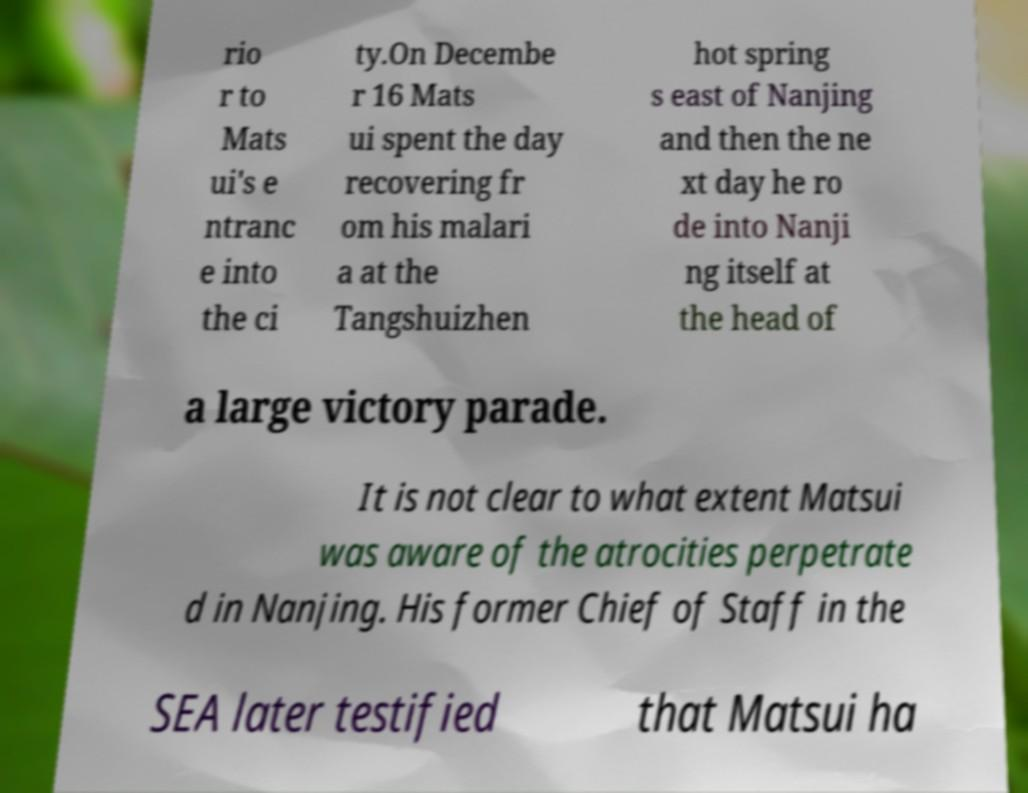For documentation purposes, I need the text within this image transcribed. Could you provide that? rio r to Mats ui's e ntranc e into the ci ty.On Decembe r 16 Mats ui spent the day recovering fr om his malari a at the Tangshuizhen hot spring s east of Nanjing and then the ne xt day he ro de into Nanji ng itself at the head of a large victory parade. It is not clear to what extent Matsui was aware of the atrocities perpetrate d in Nanjing. His former Chief of Staff in the SEA later testified that Matsui ha 